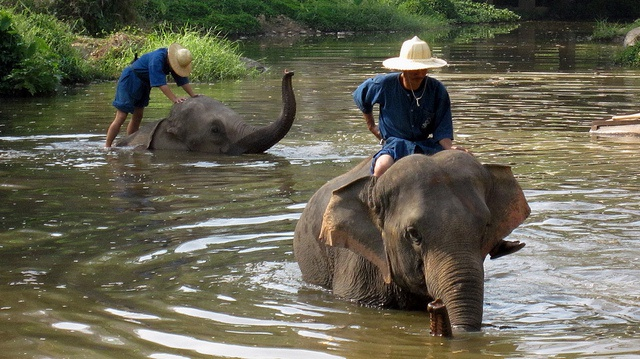Describe the objects in this image and their specific colors. I can see elephant in darkgreen, black, gray, and maroon tones, people in darkgreen, black, white, gray, and navy tones, elephant in darkgreen, black, and gray tones, and people in darkgreen, black, navy, gray, and olive tones in this image. 